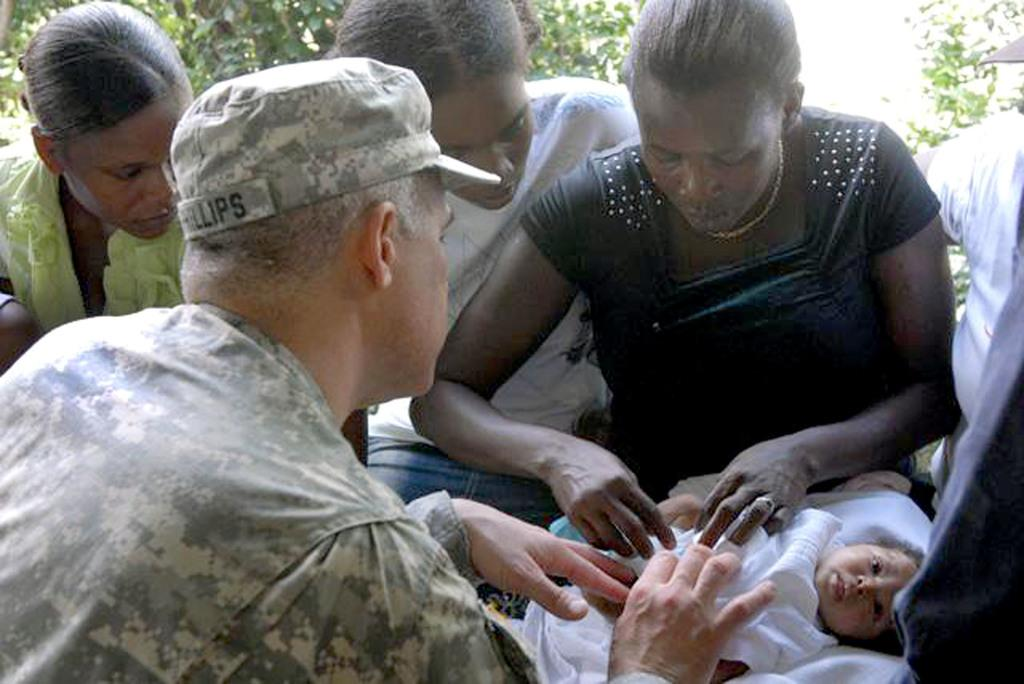What are the people in the image doing? The people in the image are sitting. Where is the baby located in the image? The baby is in the bottom right side of the image. What can be seen in the background of the image? There are trees visible in the image. What type of yarn is being used to create the baby's clothing in the image? There is no yarn present in the image, and the baby's clothing cannot be determined from the image. What order are the people sitting in the image? The order in which the people are sitting cannot be determined from the image, as there is no specific arrangement or sequence shown. 